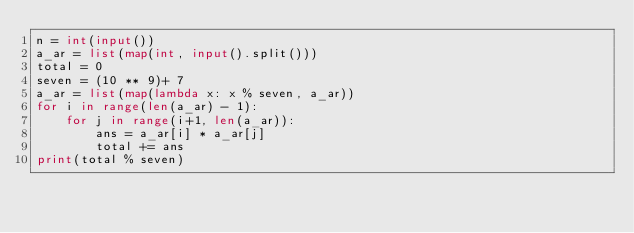Convert code to text. <code><loc_0><loc_0><loc_500><loc_500><_Python_>n = int(input())
a_ar = list(map(int, input().split()))
total = 0
seven = (10 ** 9)+ 7
a_ar = list(map(lambda x: x % seven, a_ar))
for i in range(len(a_ar) - 1):
    for j in range(i+1, len(a_ar)):
        ans = a_ar[i] * a_ar[j]
        total += ans
print(total % seven)
</code> 